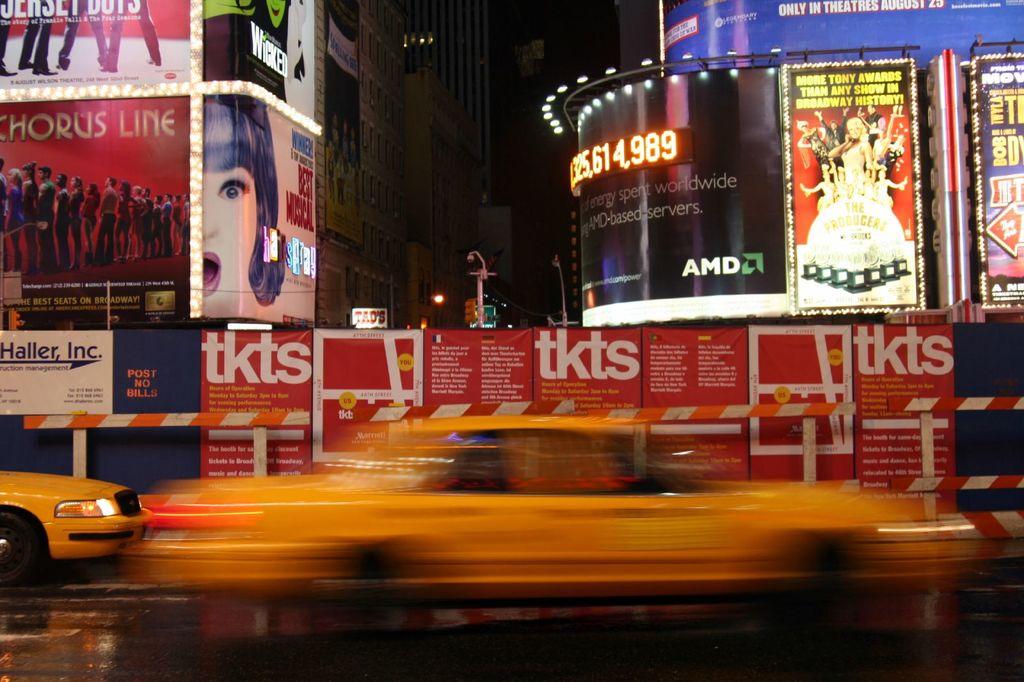What company is on the black billboard / ad?
Ensure brevity in your answer.  Amd. What does the red billboard say?
Provide a succinct answer. Tkts. 